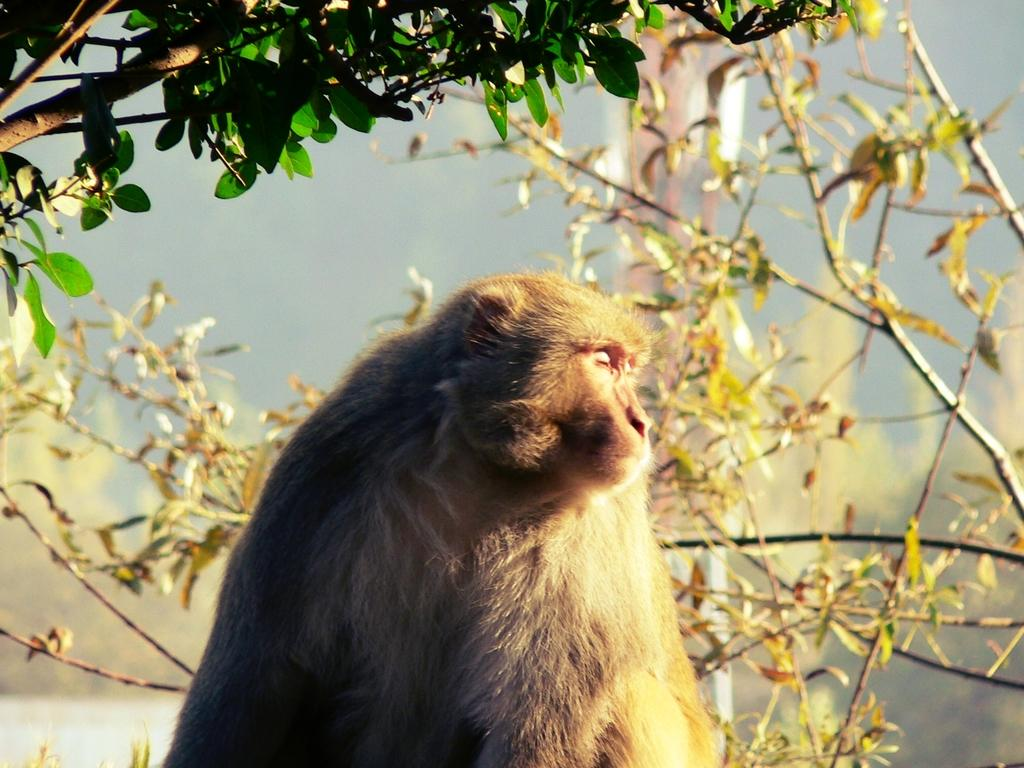What type of animal is in the image? There is a monkey in the image. What else can be seen in the image besides the monkey? There are stems with leaves and plants on the land in the image. What type of berry is the monkey holding in the image? There is no berry present in the image; the monkey is not holding anything. 